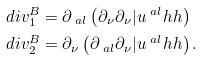<formula> <loc_0><loc_0><loc_500><loc_500>d i v ^ { B } _ { 1 } & = \partial _ { \ a l } \left ( \partial _ { \nu } \partial _ { \nu } | u ^ { \ a l } h h \right ) \\ d i v ^ { B } _ { 2 } & = \partial _ { \nu } \left ( \partial _ { \ a l } \partial _ { \nu } | u ^ { \ a l } h h \right ) .</formula> 